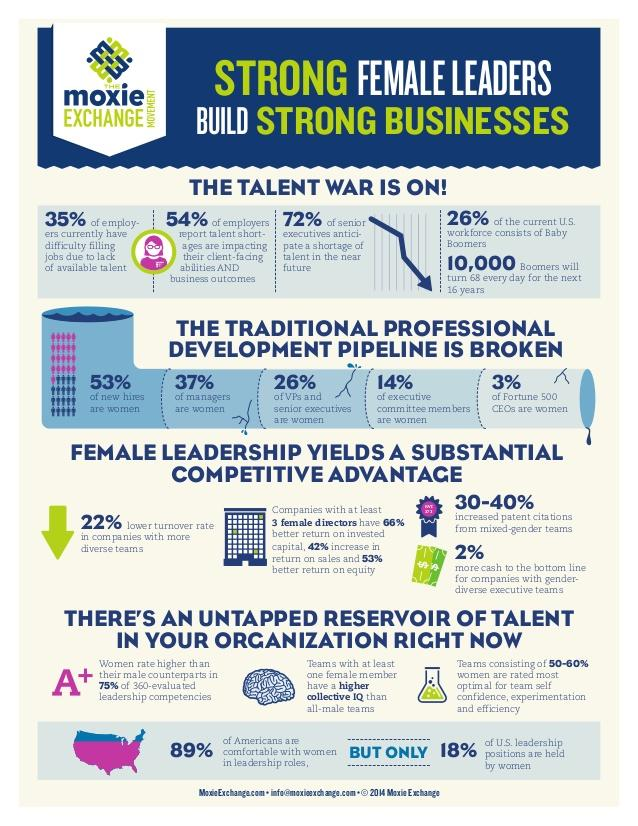Identify some key points in this picture. Out of all Fortune 500 CEOs, 97% are not women. A recent study found that 63% of managers are not women. According to a recent study, only 18% of leadership positions in the United States are held by women. According to a recent survey, 74% of VPs and senior executives are not women. Eighty-six percent of executive committee members are not women. 